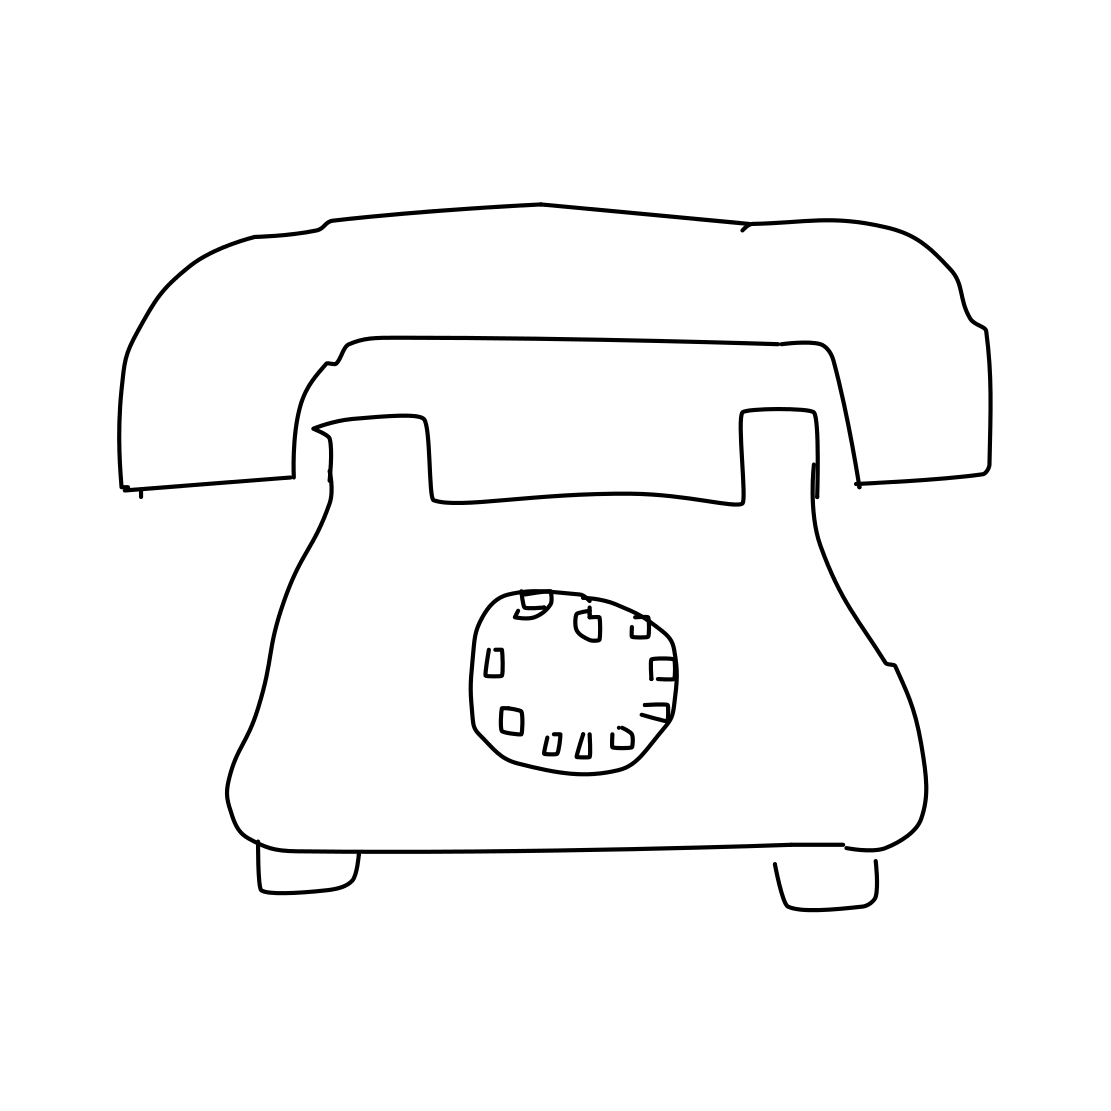Could this image be used for educational purposes? Absolutely. This image could be used to educate people on the evolution of telecommunications and to compare and contrast past technologies with today's modern devices. In what way could teachers incorporate it into a lesson plan? Teachers could use this image as part of a history lesson on technological advancements, or as a prompt for discussions on how communication has changed over the years, or even as a starting point for a hands-on activity to teach children how to read and use rotary dials. 